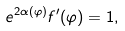Convert formula to latex. <formula><loc_0><loc_0><loc_500><loc_500>e ^ { 2 \alpha ( \varphi ) } f ^ { \prime } ( \varphi ) = 1 ,</formula> 